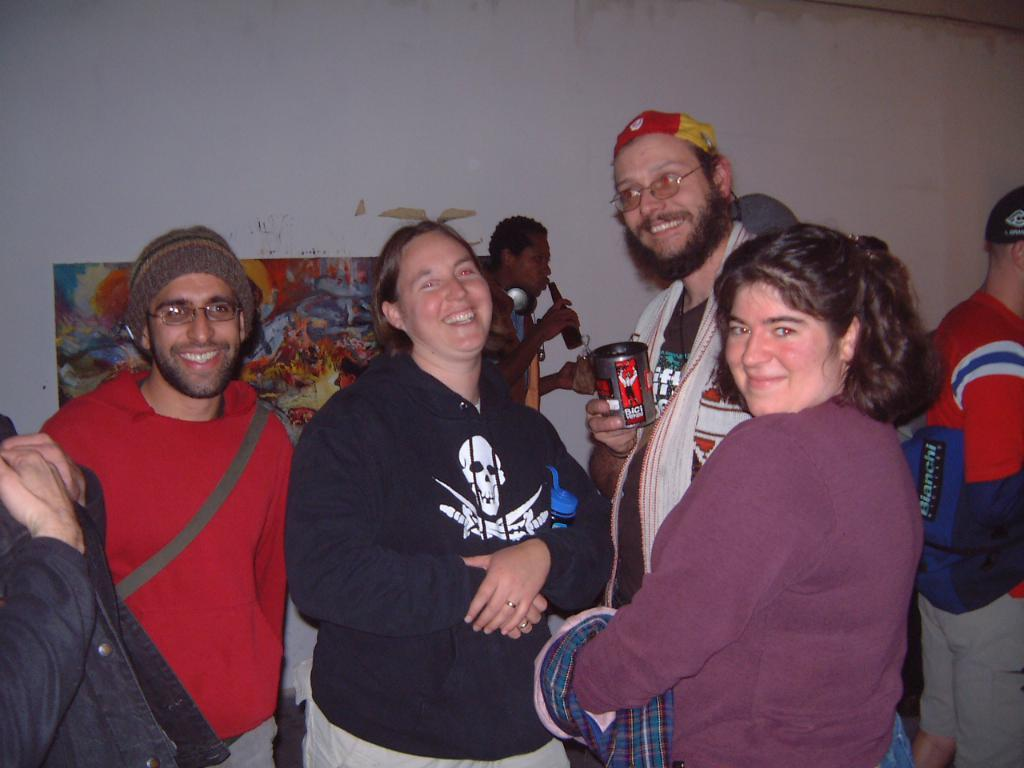How many people are in the image? There are people in the image, but the exact number is not specified. What are some people doing in the image? Some people are holding objects in the image. What can be seen in the background of the image? There is a wall in the image. What is on the wall in the image? There is a poster with art in the image. What advice is the grandmother giving to the protesters in the image? There is no mention of a grandmother or protesters in the image, so this question cannot be answered definitively. What is the color of the sky in the image? The facts provided do not mention the sky, so it is impossible to determine its color from the given information. 